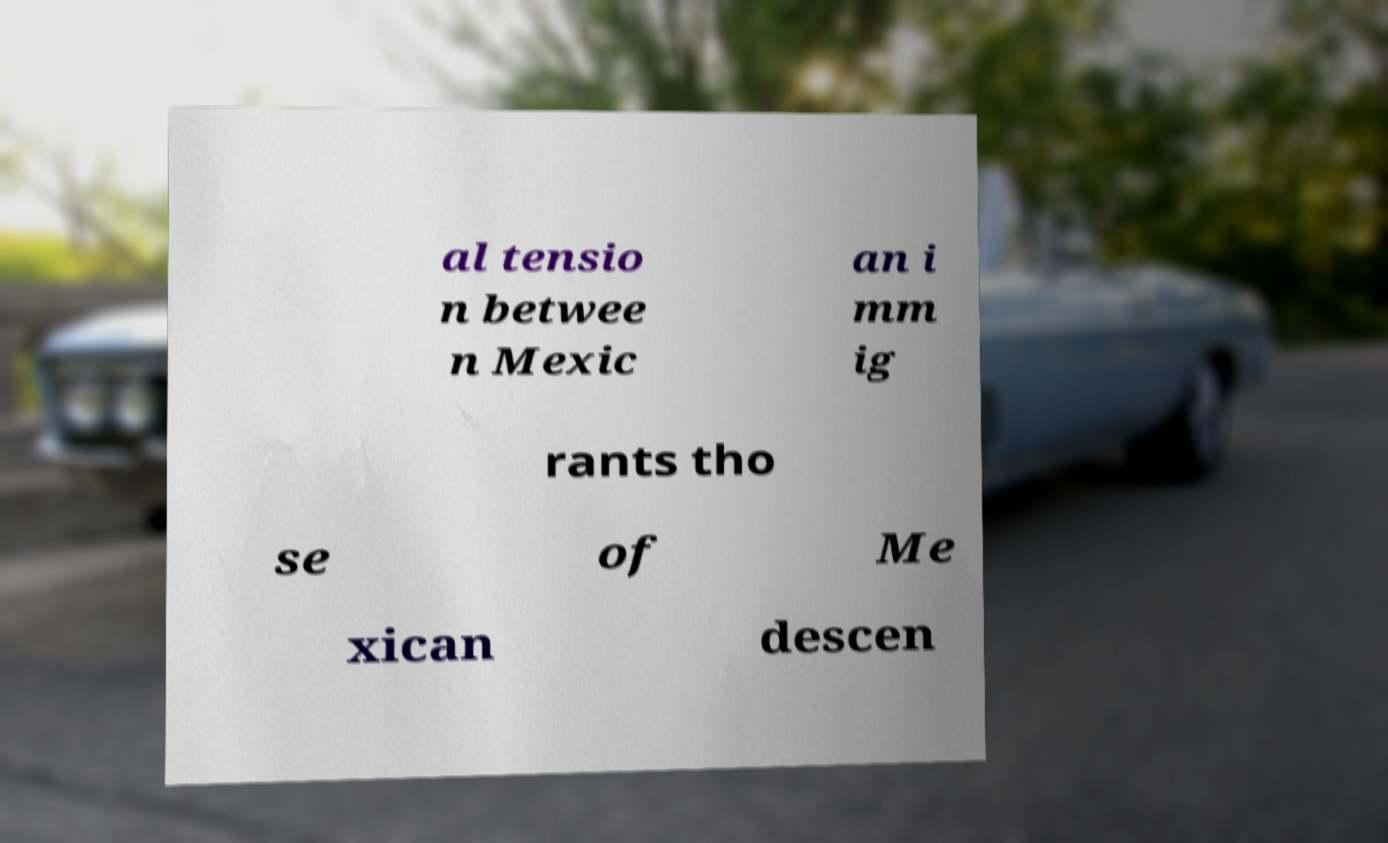What messages or text are displayed in this image? I need them in a readable, typed format. al tensio n betwee n Mexic an i mm ig rants tho se of Me xican descen 